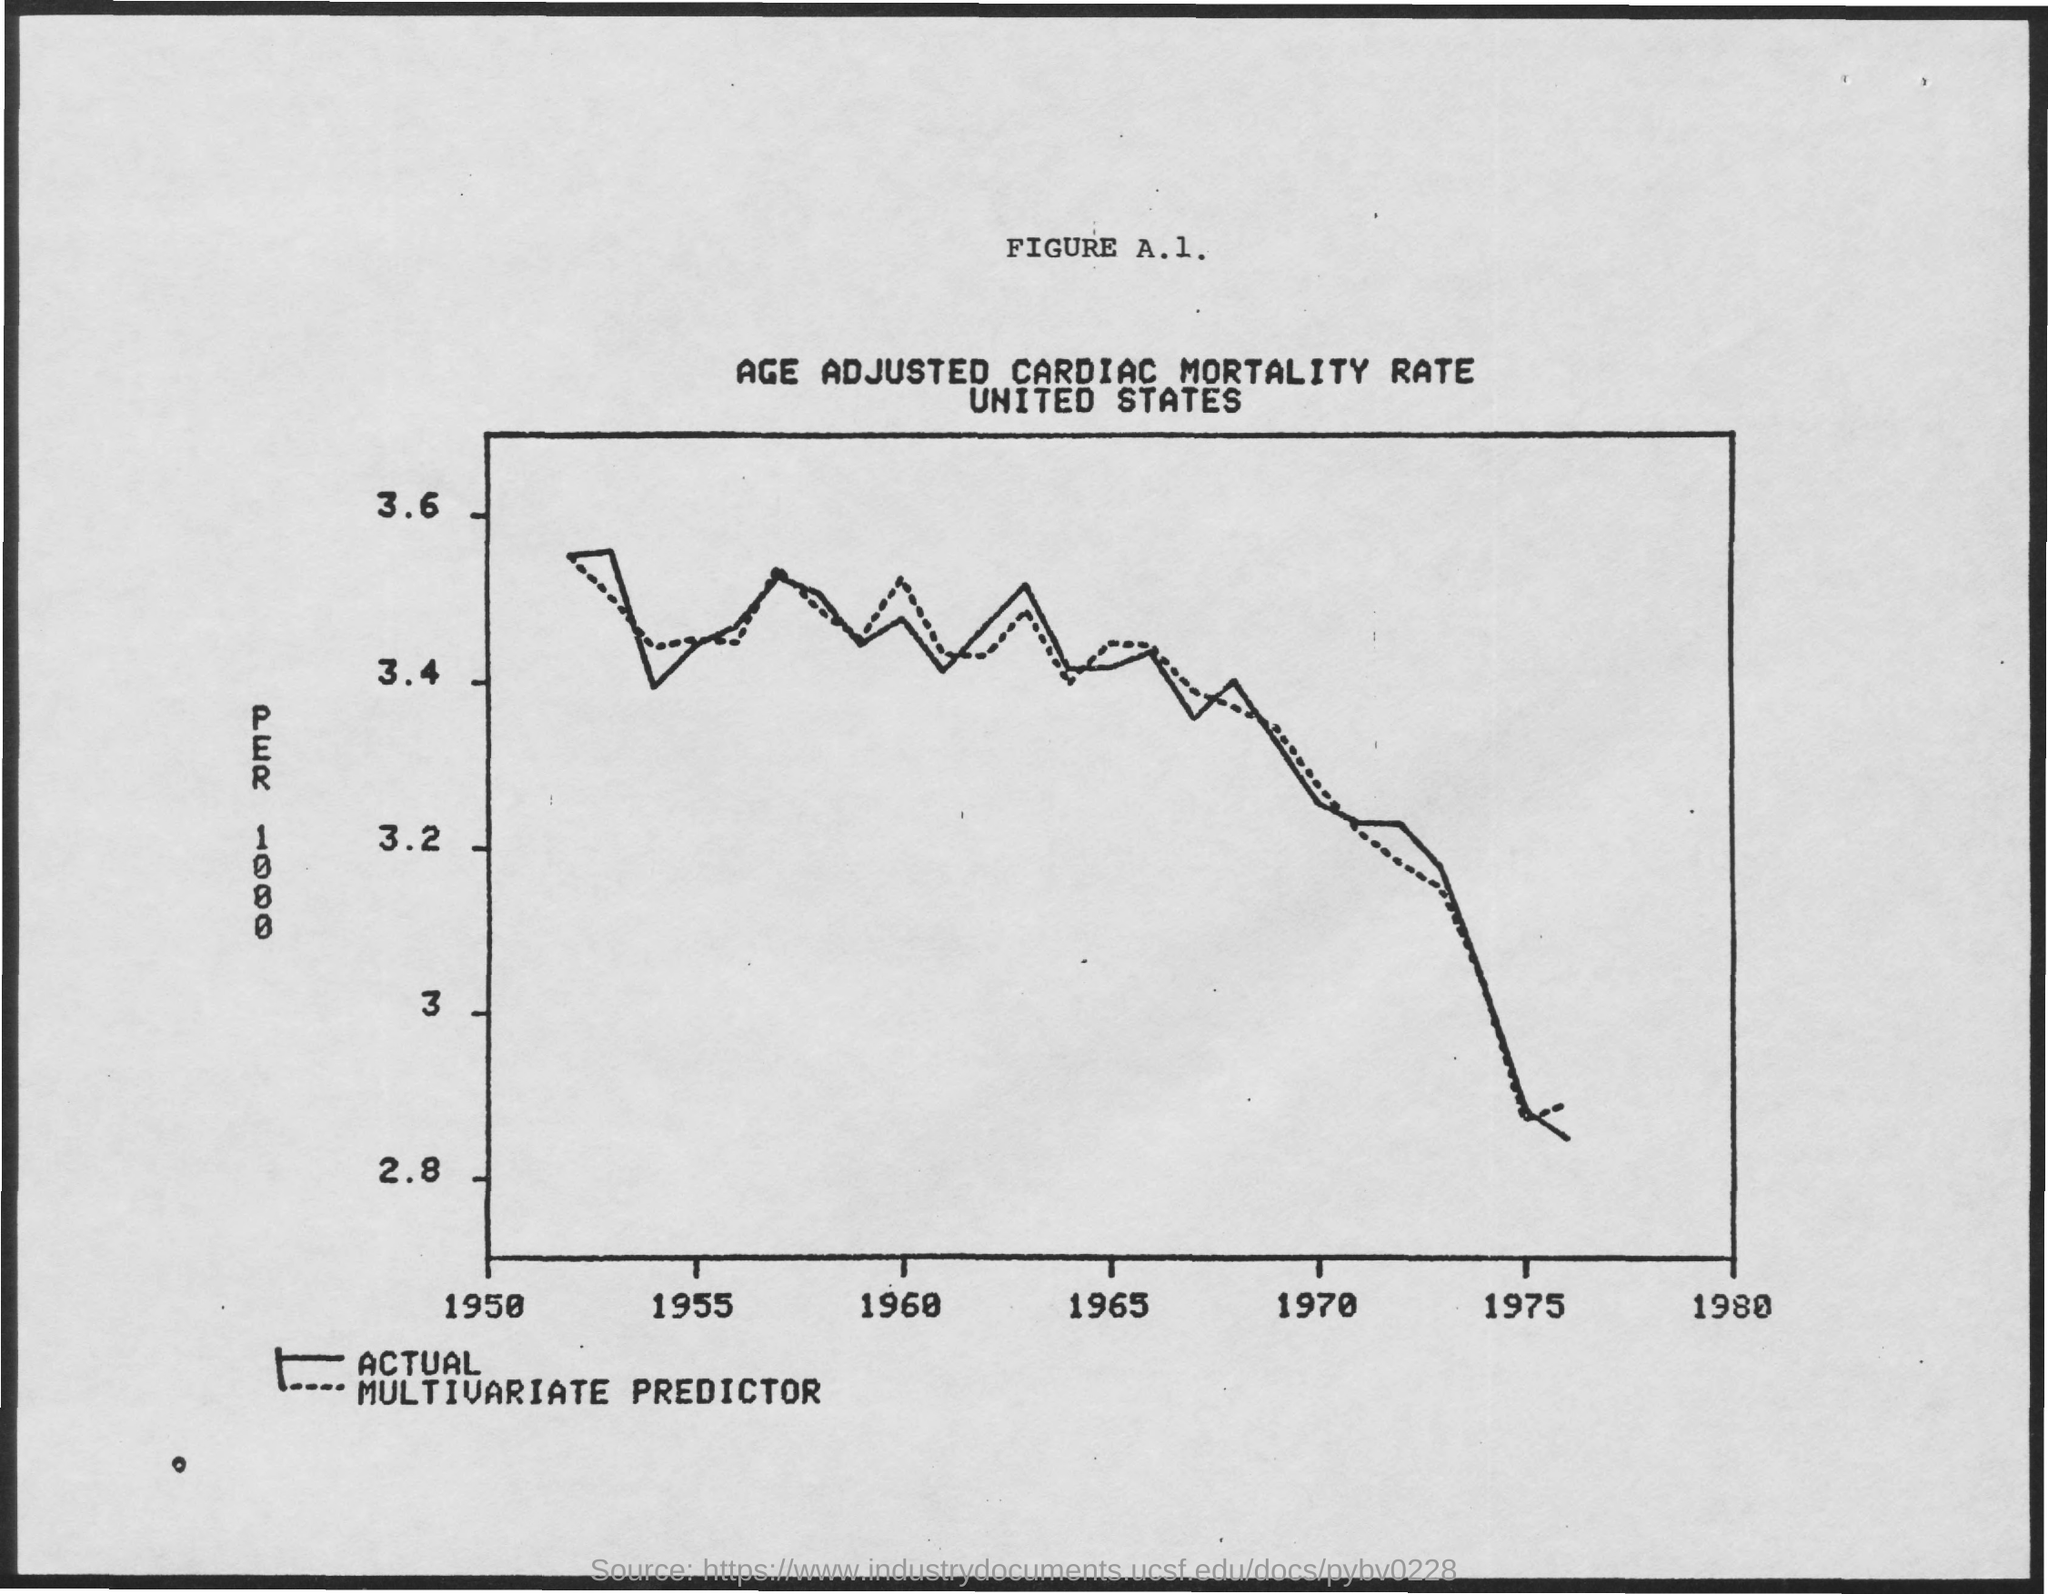What is the title of FIGURE A.1.?
Offer a very short reply. AGE ADJUSTED CARDIAC MORTALITY RATE. 